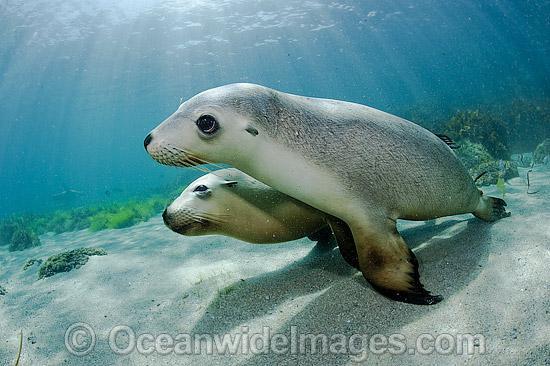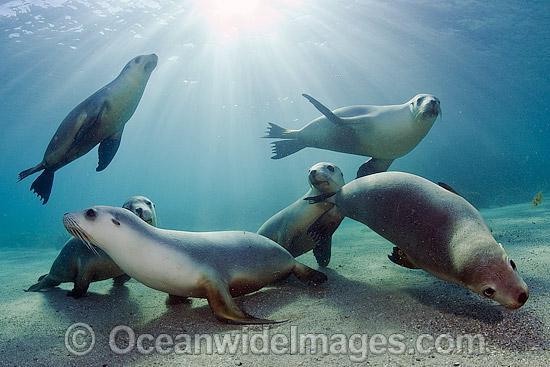The first image is the image on the left, the second image is the image on the right. For the images displayed, is the sentence "There are more than three seals in the water in the image on the right." factually correct? Answer yes or no. Yes. The first image is the image on the left, the second image is the image on the right. Examine the images to the left and right. Is the description "There is no more than two seals in the right image." accurate? Answer yes or no. No. 